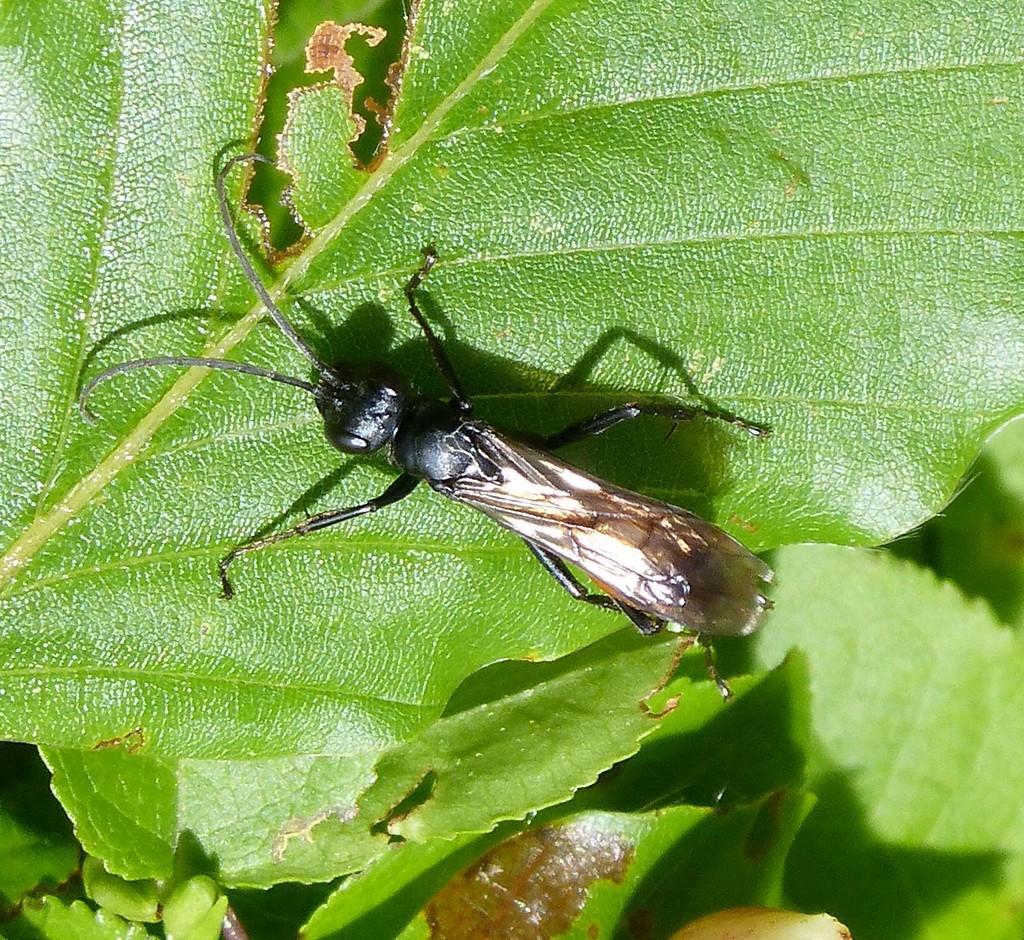Can you describe this image briefly? In this picture there is an insect on the leaf. At the bottom there is a plant. 